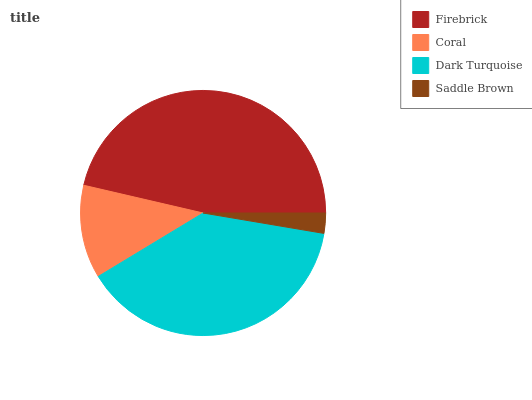Is Saddle Brown the minimum?
Answer yes or no. Yes. Is Firebrick the maximum?
Answer yes or no. Yes. Is Coral the minimum?
Answer yes or no. No. Is Coral the maximum?
Answer yes or no. No. Is Firebrick greater than Coral?
Answer yes or no. Yes. Is Coral less than Firebrick?
Answer yes or no. Yes. Is Coral greater than Firebrick?
Answer yes or no. No. Is Firebrick less than Coral?
Answer yes or no. No. Is Dark Turquoise the high median?
Answer yes or no. Yes. Is Coral the low median?
Answer yes or no. Yes. Is Firebrick the high median?
Answer yes or no. No. Is Saddle Brown the low median?
Answer yes or no. No. 